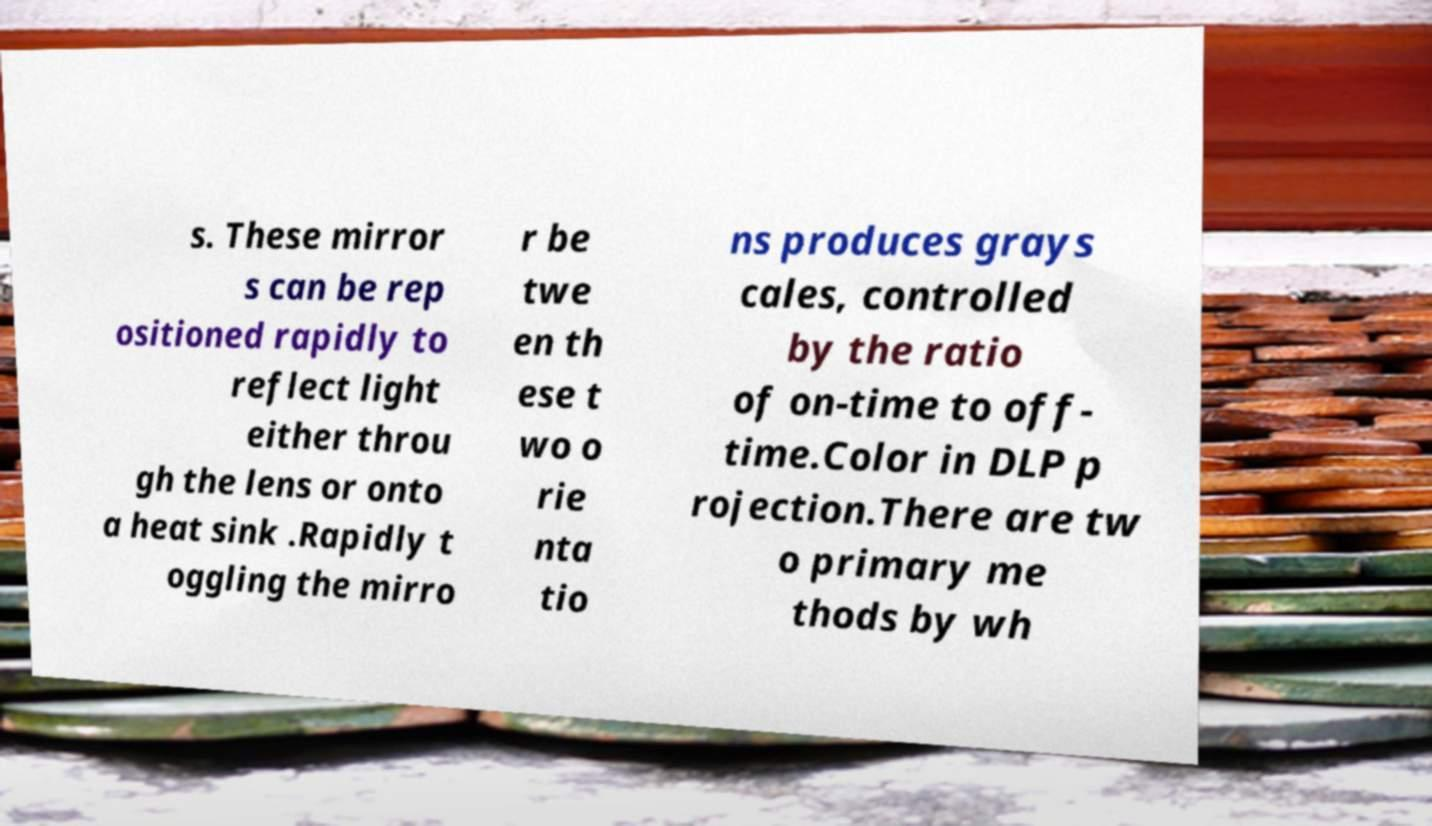I need the written content from this picture converted into text. Can you do that? s. These mirror s can be rep ositioned rapidly to reflect light either throu gh the lens or onto a heat sink .Rapidly t oggling the mirro r be twe en th ese t wo o rie nta tio ns produces grays cales, controlled by the ratio of on-time to off- time.Color in DLP p rojection.There are tw o primary me thods by wh 